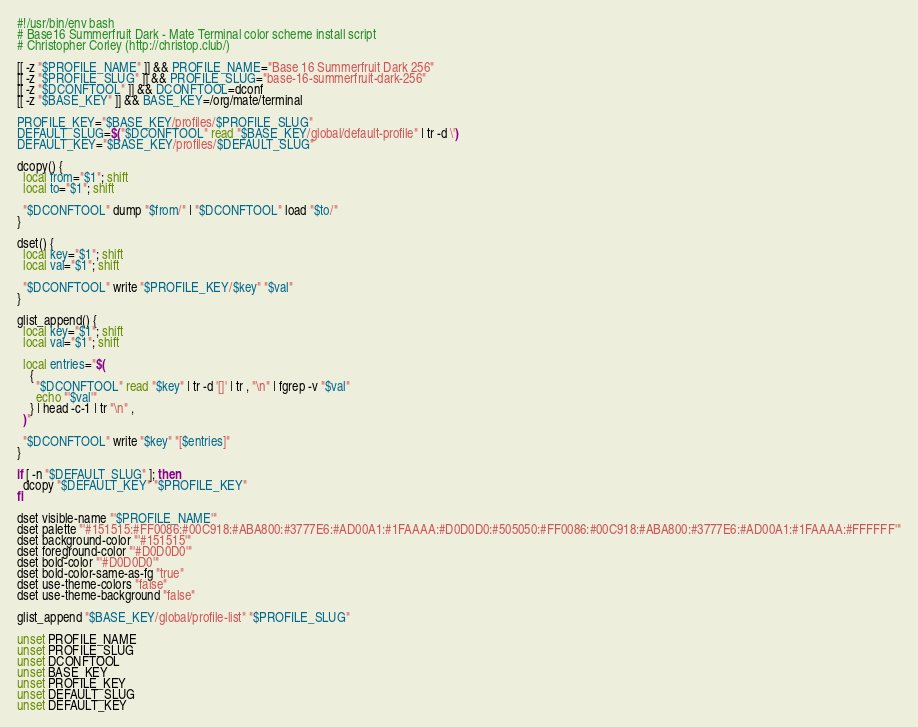Convert code to text. <code><loc_0><loc_0><loc_500><loc_500><_Bash_>#!/usr/bin/env bash
# Base16 Summerfruit Dark - Mate Terminal color scheme install script
# Christopher Corley (http://christop.club/)

[[ -z "$PROFILE_NAME" ]] && PROFILE_NAME="Base 16 Summerfruit Dark 256"
[[ -z "$PROFILE_SLUG" ]] && PROFILE_SLUG="base-16-summerfruit-dark-256"
[[ -z "$DCONFTOOL" ]] && DCONFTOOL=dconf
[[ -z "$BASE_KEY" ]] && BASE_KEY=/org/mate/terminal

PROFILE_KEY="$BASE_KEY/profiles/$PROFILE_SLUG"
DEFAULT_SLUG=$("$DCONFTOOL" read "$BASE_KEY/global/default-profile" | tr -d \')
DEFAULT_KEY="$BASE_KEY/profiles/$DEFAULT_SLUG"

dcopy() {
  local from="$1"; shift
  local to="$1"; shift

  "$DCONFTOOL" dump "$from/" | "$DCONFTOOL" load "$to/"
}

dset() {
  local key="$1"; shift
  local val="$1"; shift

  "$DCONFTOOL" write "$PROFILE_KEY/$key" "$val"
}

glist_append() {
  local key="$1"; shift
  local val="$1"; shift

  local entries="$(
    {
      "$DCONFTOOL" read "$key" | tr -d '[]' | tr , "\n" | fgrep -v "$val"
      echo "'$val'"
    } | head -c-1 | tr "\n" ,
  )"

  "$DCONFTOOL" write "$key" "[$entries]"
}

if [ -n "$DEFAULT_SLUG" ]; then
  dcopy "$DEFAULT_KEY" "$PROFILE_KEY"
fi

dset visible-name "'$PROFILE_NAME'"
dset palette "'#151515:#FF0086:#00C918:#ABA800:#3777E6:#AD00A1:#1FAAAA:#D0D0D0:#505050:#FF0086:#00C918:#ABA800:#3777E6:#AD00A1:#1FAAAA:#FFFFFF'"
dset background-color "'#151515'"
dset foreground-color "'#D0D0D0'"
dset bold-color "'#D0D0D0'"
dset bold-color-same-as-fg "true"
dset use-theme-colors "false"
dset use-theme-background "false"

glist_append "$BASE_KEY/global/profile-list" "$PROFILE_SLUG"

unset PROFILE_NAME
unset PROFILE_SLUG
unset DCONFTOOL
unset BASE_KEY
unset PROFILE_KEY
unset DEFAULT_SLUG
unset DEFAULT_KEY
</code> 